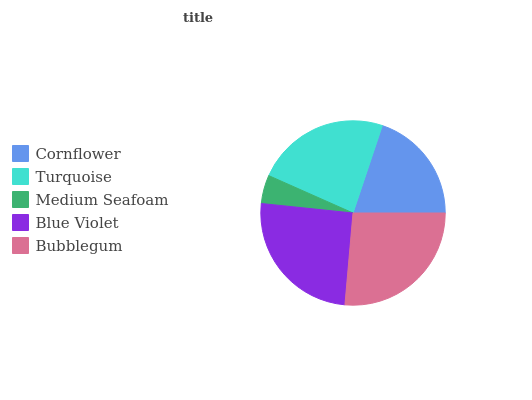Is Medium Seafoam the minimum?
Answer yes or no. Yes. Is Bubblegum the maximum?
Answer yes or no. Yes. Is Turquoise the minimum?
Answer yes or no. No. Is Turquoise the maximum?
Answer yes or no. No. Is Turquoise greater than Cornflower?
Answer yes or no. Yes. Is Cornflower less than Turquoise?
Answer yes or no. Yes. Is Cornflower greater than Turquoise?
Answer yes or no. No. Is Turquoise less than Cornflower?
Answer yes or no. No. Is Turquoise the high median?
Answer yes or no. Yes. Is Turquoise the low median?
Answer yes or no. Yes. Is Medium Seafoam the high median?
Answer yes or no. No. Is Cornflower the low median?
Answer yes or no. No. 